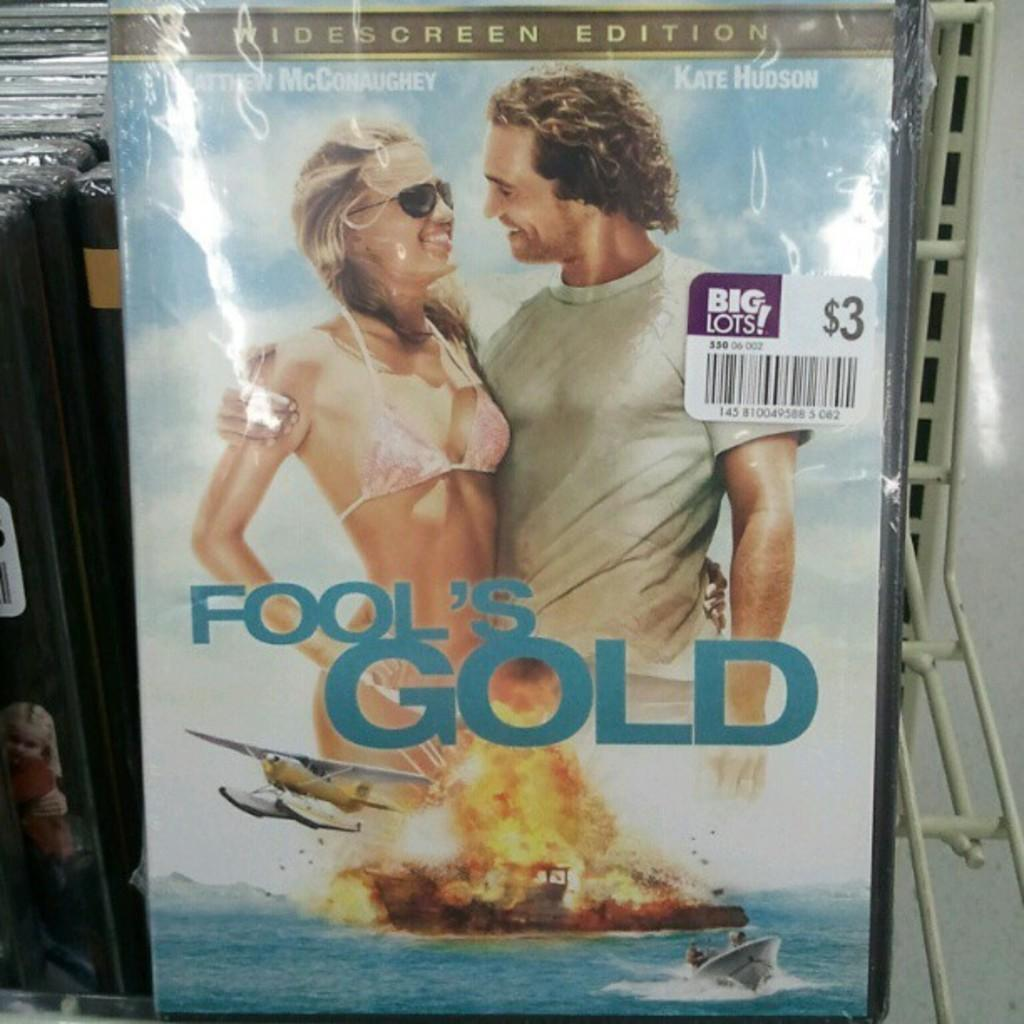<image>
Share a concise interpretation of the image provided. The movie Fools Gold is on sale at Big Lots. 